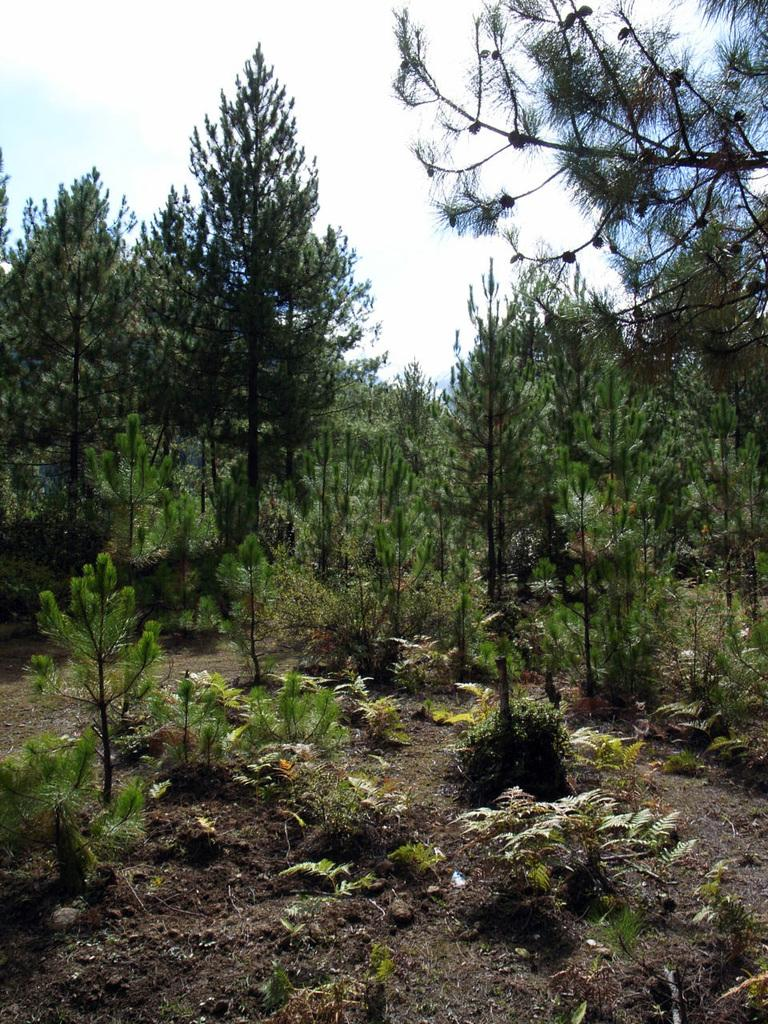What type of vegetation can be seen in the image? There are trees and plants in the image. What part of the natural environment is visible in the image? The sky is visible in the background of the image. Can you describe the vegetation in the image? The trees and plants in the image are likely part of a natural landscape or garden. What type of dolls can be seen on the stage in the image? There are no dolls or stage present in the image; it features trees, plants, and the sky. 